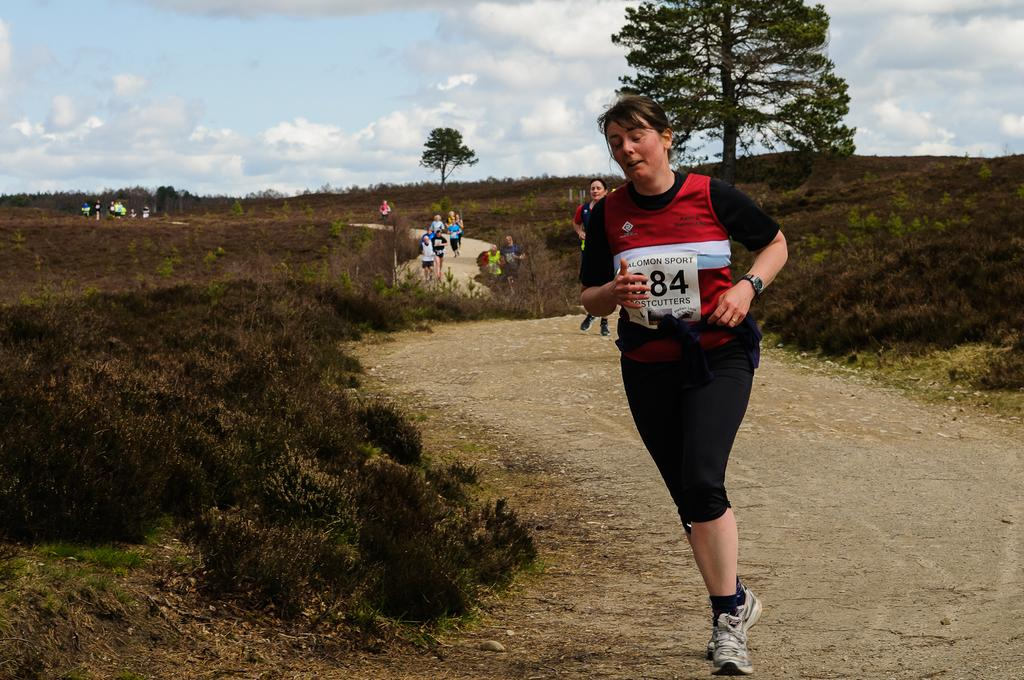What are the persons in the image doing? The persons in the image are running. Where are the persons running? The persons are running along a road. What type of vegetation can be seen in the image? There are shrubs and trees visible in the image. What part of the natural environment is visible in the image? The ground, trees, and sky are visible in the image. What is the condition of the sky in the image? The sky is visible in the image, and clouds are present. Can you tell me how many schools are visible in the image? There are no schools visible in the image; it features persons running along a road with trees, shrubs, and clouds in the sky. 